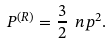<formula> <loc_0><loc_0><loc_500><loc_500>P ^ { ( R ) } = \frac { 3 } { 2 } \ n p ^ { 2 } .</formula> 